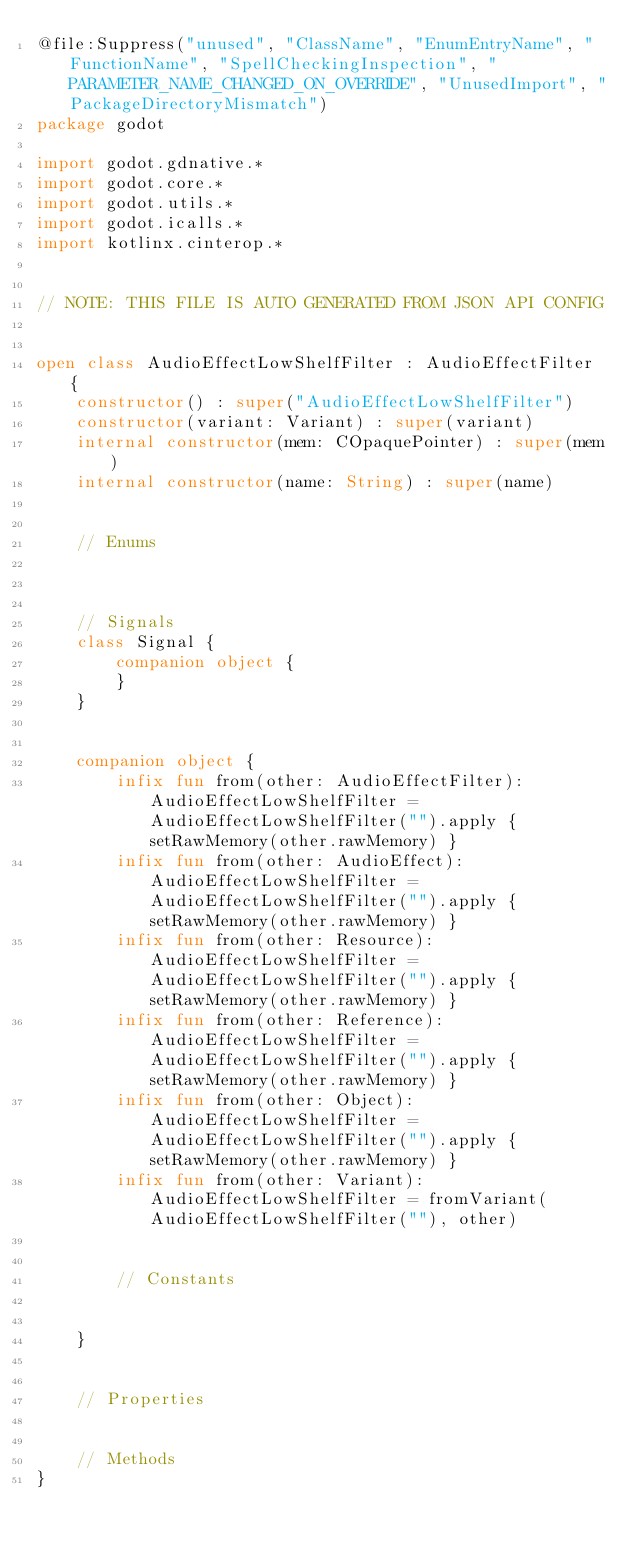<code> <loc_0><loc_0><loc_500><loc_500><_Kotlin_>@file:Suppress("unused", "ClassName", "EnumEntryName", "FunctionName", "SpellCheckingInspection", "PARAMETER_NAME_CHANGED_ON_OVERRIDE", "UnusedImport", "PackageDirectoryMismatch")
package godot

import godot.gdnative.*
import godot.core.*
import godot.utils.*
import godot.icalls.*
import kotlinx.cinterop.*


// NOTE: THIS FILE IS AUTO GENERATED FROM JSON API CONFIG


open class AudioEffectLowShelfFilter : AudioEffectFilter {
    constructor() : super("AudioEffectLowShelfFilter")
    constructor(variant: Variant) : super(variant)
    internal constructor(mem: COpaquePointer) : super(mem)
    internal constructor(name: String) : super(name)


    // Enums 



    // Signals
    class Signal {
        companion object {
        }
    }


    companion object {
        infix fun from(other: AudioEffectFilter): AudioEffectLowShelfFilter = AudioEffectLowShelfFilter("").apply { setRawMemory(other.rawMemory) }
        infix fun from(other: AudioEffect): AudioEffectLowShelfFilter = AudioEffectLowShelfFilter("").apply { setRawMemory(other.rawMemory) }
        infix fun from(other: Resource): AudioEffectLowShelfFilter = AudioEffectLowShelfFilter("").apply { setRawMemory(other.rawMemory) }
        infix fun from(other: Reference): AudioEffectLowShelfFilter = AudioEffectLowShelfFilter("").apply { setRawMemory(other.rawMemory) }
        infix fun from(other: Object): AudioEffectLowShelfFilter = AudioEffectLowShelfFilter("").apply { setRawMemory(other.rawMemory) }
        infix fun from(other: Variant): AudioEffectLowShelfFilter = fromVariant(AudioEffectLowShelfFilter(""), other)


        // Constants


    }


    // Properties


    // Methods
}
</code> 